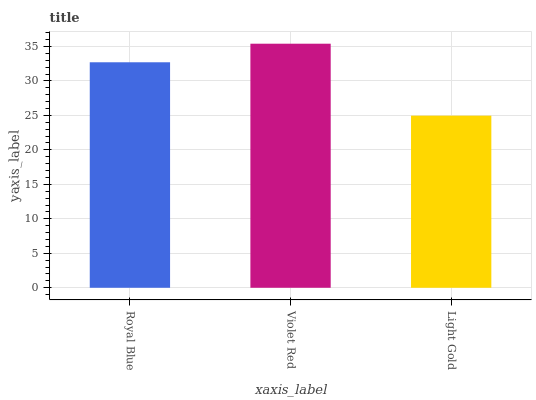Is Light Gold the minimum?
Answer yes or no. Yes. Is Violet Red the maximum?
Answer yes or no. Yes. Is Violet Red the minimum?
Answer yes or no. No. Is Light Gold the maximum?
Answer yes or no. No. Is Violet Red greater than Light Gold?
Answer yes or no. Yes. Is Light Gold less than Violet Red?
Answer yes or no. Yes. Is Light Gold greater than Violet Red?
Answer yes or no. No. Is Violet Red less than Light Gold?
Answer yes or no. No. Is Royal Blue the high median?
Answer yes or no. Yes. Is Royal Blue the low median?
Answer yes or no. Yes. Is Light Gold the high median?
Answer yes or no. No. Is Violet Red the low median?
Answer yes or no. No. 